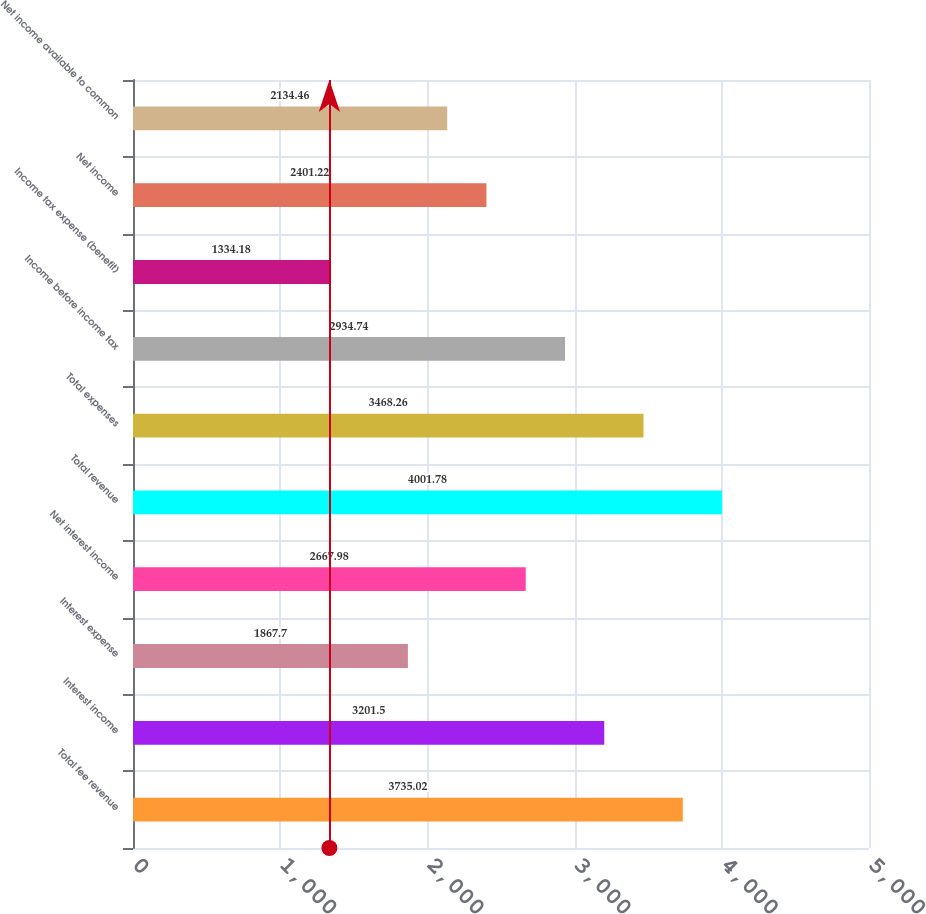Convert chart to OTSL. <chart><loc_0><loc_0><loc_500><loc_500><bar_chart><fcel>Total fee revenue<fcel>Interest income<fcel>Interest expense<fcel>Net interest income<fcel>Total revenue<fcel>Total expenses<fcel>Income before income tax<fcel>Income tax expense (benefit)<fcel>Net income<fcel>Net income available to common<nl><fcel>3735.02<fcel>3201.5<fcel>1867.7<fcel>2667.98<fcel>4001.78<fcel>3468.26<fcel>2934.74<fcel>1334.18<fcel>2401.22<fcel>2134.46<nl></chart> 